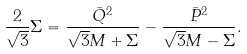<formula> <loc_0><loc_0><loc_500><loc_500>\frac { 2 } { \sqrt { 3 } } \Sigma = \frac { \bar { Q } ^ { 2 } } { \sqrt { 3 } M + \Sigma } - \frac { \bar { P } ^ { 2 } } { \sqrt { 3 } M - \Sigma } .</formula> 